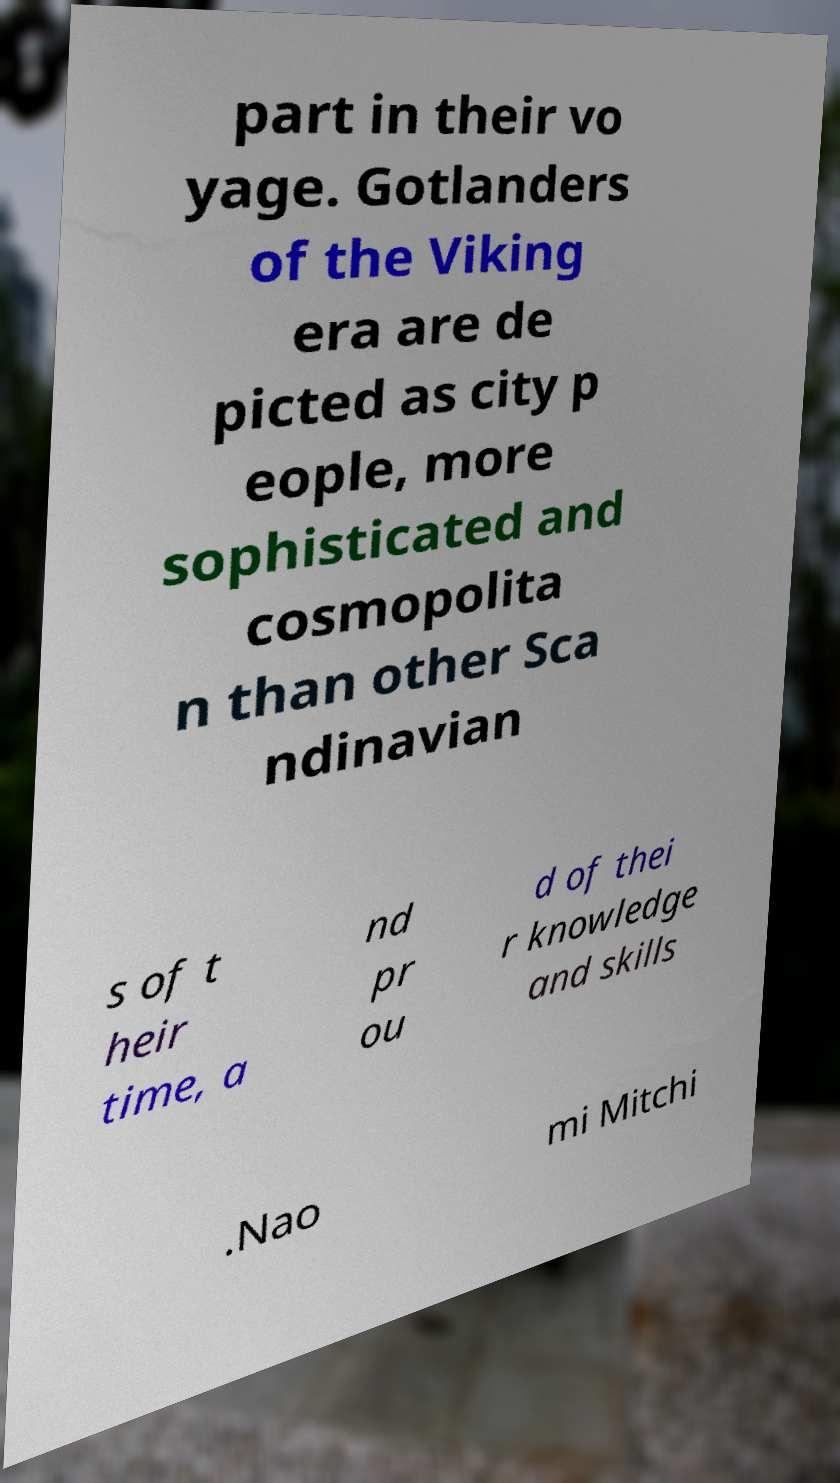What messages or text are displayed in this image? I need them in a readable, typed format. part in their vo yage. Gotlanders of the Viking era are de picted as city p eople, more sophisticated and cosmopolita n than other Sca ndinavian s of t heir time, a nd pr ou d of thei r knowledge and skills .Nao mi Mitchi 